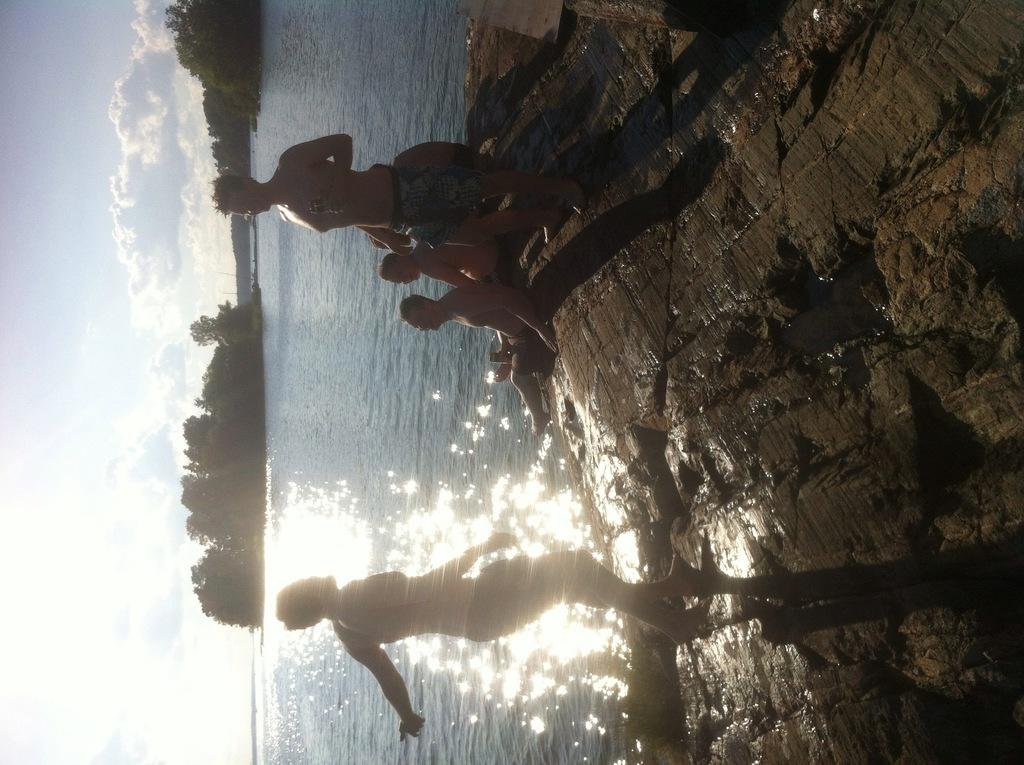What are the people in the image doing? There are persons standing and sitting on the ground in the image. Can you describe the environment in the image? There is water, trees, and the sky visible in the background of the image. What type of impulse can be seen affecting the water in the image? There is no impulse affecting the water in the image; it appears to be still. What activity is the key involved in within the image? There is no key present in the image, so it cannot be involved in any activity. 